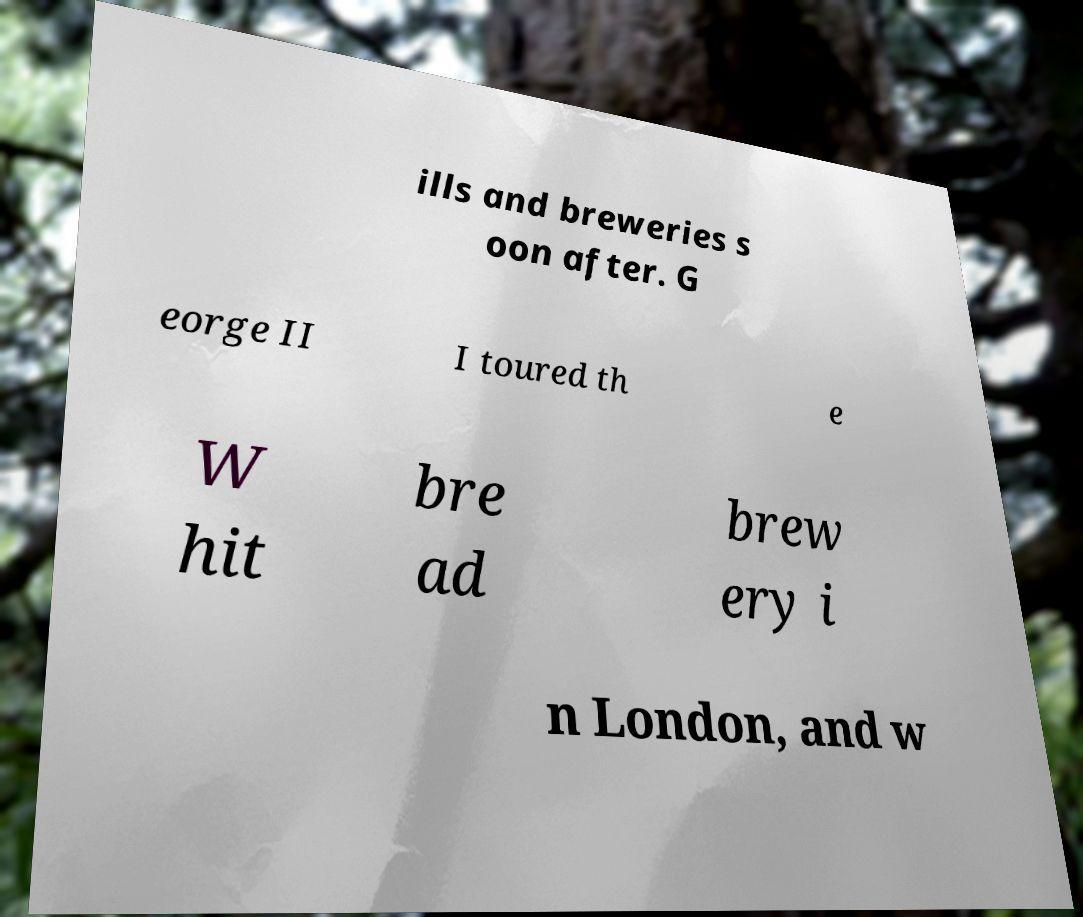Can you accurately transcribe the text from the provided image for me? ills and breweries s oon after. G eorge II I toured th e W hit bre ad brew ery i n London, and w 